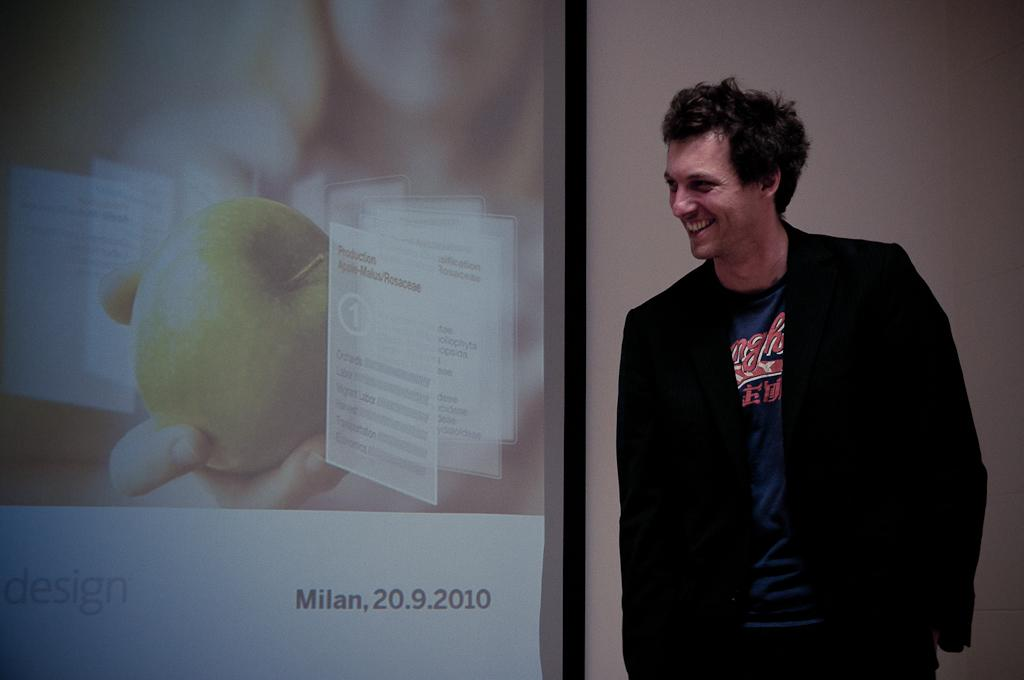<image>
Present a compact description of the photo's key features. A male stands in front of a presentation screen with the year 2010 on it. 